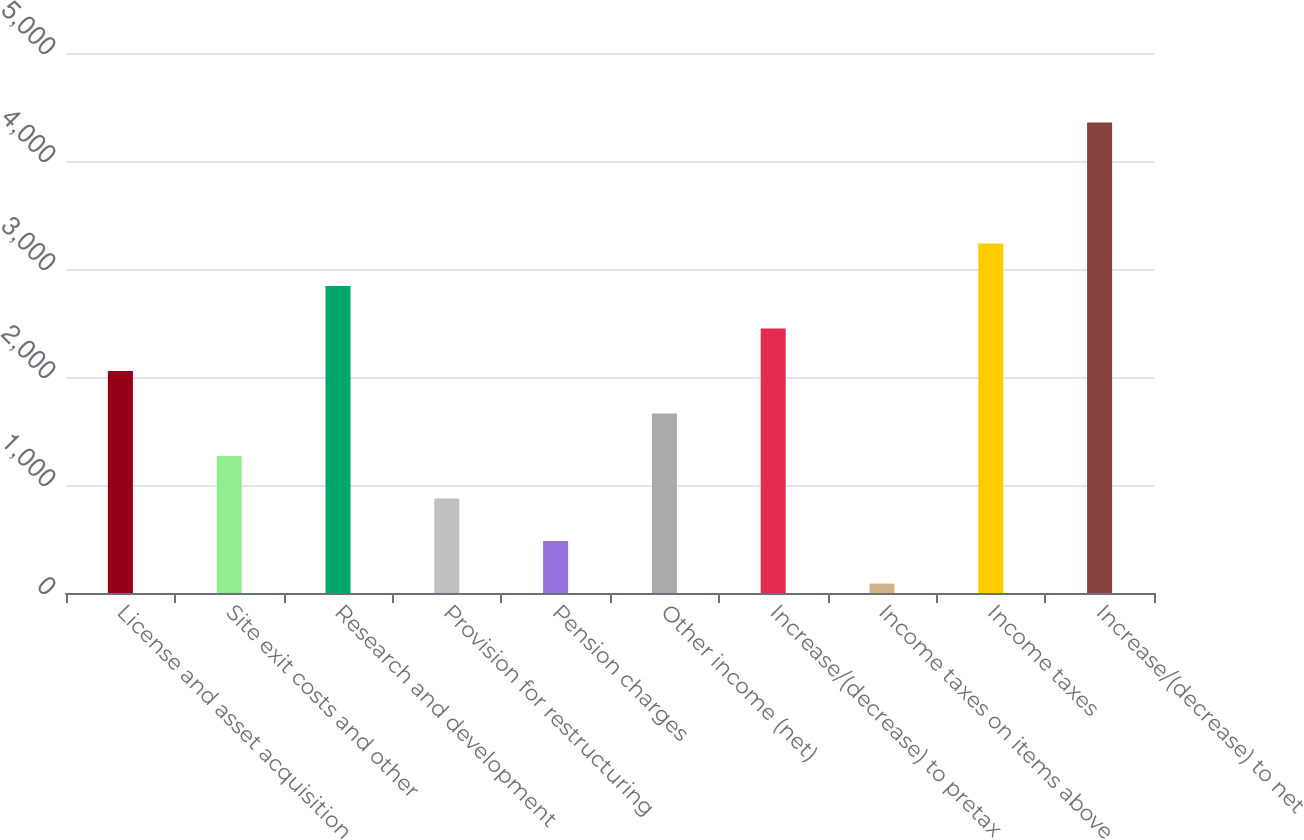<chart> <loc_0><loc_0><loc_500><loc_500><bar_chart><fcel>License and asset acquisition<fcel>Site exit costs and other<fcel>Research and development<fcel>Provision for restructuring<fcel>Pension charges<fcel>Other income (net)<fcel>Increase/(decrease) to pretax<fcel>Income taxes on items above<fcel>Income taxes<fcel>Increase/(decrease) to net<nl><fcel>2054.5<fcel>1267.5<fcel>2841.5<fcel>874<fcel>480.5<fcel>1661<fcel>2448<fcel>87<fcel>3235<fcel>4356.5<nl></chart> 